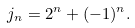<formula> <loc_0><loc_0><loc_500><loc_500>j _ { n } = 2 ^ { n } + ( - 1 ) ^ { n } .</formula> 